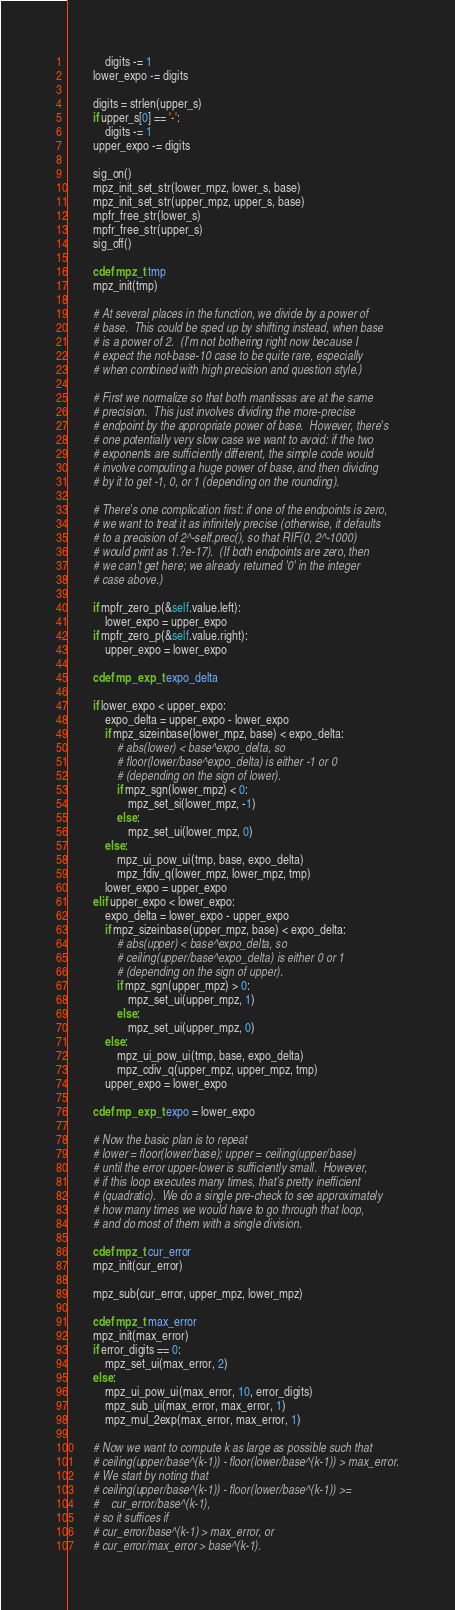<code> <loc_0><loc_0><loc_500><loc_500><_Cython_>            digits -= 1
        lower_expo -= digits

        digits = strlen(upper_s)
        if upper_s[0] == '-':
            digits -= 1
        upper_expo -= digits

        sig_on()
        mpz_init_set_str(lower_mpz, lower_s, base)
        mpz_init_set_str(upper_mpz, upper_s, base)
        mpfr_free_str(lower_s)
        mpfr_free_str(upper_s)
        sig_off()

        cdef mpz_t tmp
        mpz_init(tmp)

        # At several places in the function, we divide by a power of
        # base.  This could be sped up by shifting instead, when base
        # is a power of 2.  (I'm not bothering right now because I
        # expect the not-base-10 case to be quite rare, especially
        # when combined with high precision and question style.)

        # First we normalize so that both mantissas are at the same
        # precision.  This just involves dividing the more-precise
        # endpoint by the appropriate power of base.  However, there's
        # one potentially very slow case we want to avoid: if the two
        # exponents are sufficiently different, the simple code would
        # involve computing a huge power of base, and then dividing
        # by it to get -1, 0, or 1 (depending on the rounding).

        # There's one complication first: if one of the endpoints is zero,
        # we want to treat it as infinitely precise (otherwise, it defaults
        # to a precision of 2^-self.prec(), so that RIF(0, 2^-1000)
        # would print as 1.?e-17).  (If both endpoints are zero, then
        # we can't get here; we already returned '0' in the integer
        # case above.)

        if mpfr_zero_p(&self.value.left):
            lower_expo = upper_expo
        if mpfr_zero_p(&self.value.right):
            upper_expo = lower_expo

        cdef mp_exp_t expo_delta

        if lower_expo < upper_expo:
            expo_delta = upper_expo - lower_expo
            if mpz_sizeinbase(lower_mpz, base) < expo_delta:
                # abs(lower) < base^expo_delta, so
                # floor(lower/base^expo_delta) is either -1 or 0
                # (depending on the sign of lower).
                if mpz_sgn(lower_mpz) < 0:
                    mpz_set_si(lower_mpz, -1)
                else:
                    mpz_set_ui(lower_mpz, 0)
            else:
                mpz_ui_pow_ui(tmp, base, expo_delta)
                mpz_fdiv_q(lower_mpz, lower_mpz, tmp)
            lower_expo = upper_expo
        elif upper_expo < lower_expo:
            expo_delta = lower_expo - upper_expo
            if mpz_sizeinbase(upper_mpz, base) < expo_delta:
                # abs(upper) < base^expo_delta, so
                # ceiling(upper/base^expo_delta) is either 0 or 1
                # (depending on the sign of upper).
                if mpz_sgn(upper_mpz) > 0:
                    mpz_set_ui(upper_mpz, 1)
                else:
                    mpz_set_ui(upper_mpz, 0)
            else:
                mpz_ui_pow_ui(tmp, base, expo_delta)
                mpz_cdiv_q(upper_mpz, upper_mpz, tmp)
            upper_expo = lower_expo

        cdef mp_exp_t expo = lower_expo

        # Now the basic plan is to repeat
        # lower = floor(lower/base); upper = ceiling(upper/base)
        # until the error upper-lower is sufficiently small.  However,
        # if this loop executes many times, that's pretty inefficient
        # (quadratic).  We do a single pre-check to see approximately
        # how many times we would have to go through that loop,
        # and do most of them with a single division.

        cdef mpz_t cur_error
        mpz_init(cur_error)

        mpz_sub(cur_error, upper_mpz, lower_mpz)

        cdef mpz_t max_error
        mpz_init(max_error)
        if error_digits == 0:
            mpz_set_ui(max_error, 2)
        else:
            mpz_ui_pow_ui(max_error, 10, error_digits)
            mpz_sub_ui(max_error, max_error, 1)
            mpz_mul_2exp(max_error, max_error, 1)

        # Now we want to compute k as large as possible such that
        # ceiling(upper/base^(k-1)) - floor(lower/base^(k-1)) > max_error.
        # We start by noting that
        # ceiling(upper/base^(k-1)) - floor(lower/base^(k-1)) >=
        #    cur_error/base^(k-1),
        # so it suffices if
        # cur_error/base^(k-1) > max_error, or
        # cur_error/max_error > base^(k-1).
</code> 